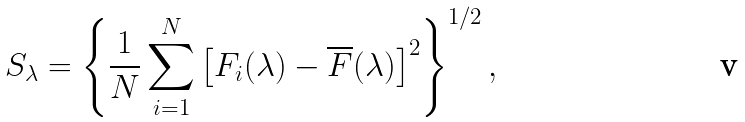<formula> <loc_0><loc_0><loc_500><loc_500>S _ { \lambda } = \left \{ \frac { 1 } { N } \sum _ { i = 1 } ^ { N } \left [ F _ { i } ( \lambda ) - \overline { F } ( \lambda ) \right ] ^ { 2 } \right \} ^ { 1 / 2 } ,</formula> 